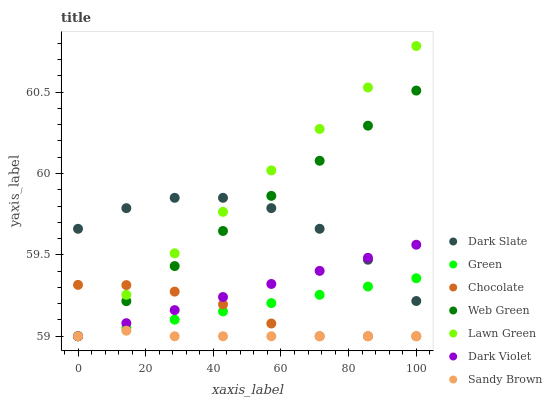Does Sandy Brown have the minimum area under the curve?
Answer yes or no. Yes. Does Lawn Green have the maximum area under the curve?
Answer yes or no. Yes. Does Dark Violet have the minimum area under the curve?
Answer yes or no. No. Does Dark Violet have the maximum area under the curve?
Answer yes or no. No. Is Green the smoothest?
Answer yes or no. Yes. Is Dark Slate the roughest?
Answer yes or no. Yes. Is Dark Violet the smoothest?
Answer yes or no. No. Is Dark Violet the roughest?
Answer yes or no. No. Does Lawn Green have the lowest value?
Answer yes or no. Yes. Does Dark Slate have the lowest value?
Answer yes or no. No. Does Lawn Green have the highest value?
Answer yes or no. Yes. Does Dark Violet have the highest value?
Answer yes or no. No. Is Chocolate less than Dark Slate?
Answer yes or no. Yes. Is Dark Slate greater than Sandy Brown?
Answer yes or no. Yes. Does Lawn Green intersect Dark Slate?
Answer yes or no. Yes. Is Lawn Green less than Dark Slate?
Answer yes or no. No. Is Lawn Green greater than Dark Slate?
Answer yes or no. No. Does Chocolate intersect Dark Slate?
Answer yes or no. No. 